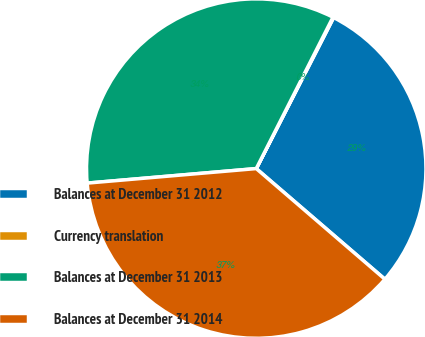Convert chart. <chart><loc_0><loc_0><loc_500><loc_500><pie_chart><fcel>Balances at December 31 2012<fcel>Currency translation<fcel>Balances at December 31 2013<fcel>Balances at December 31 2014<nl><fcel>28.77%<fcel>0.07%<fcel>33.83%<fcel>37.33%<nl></chart> 